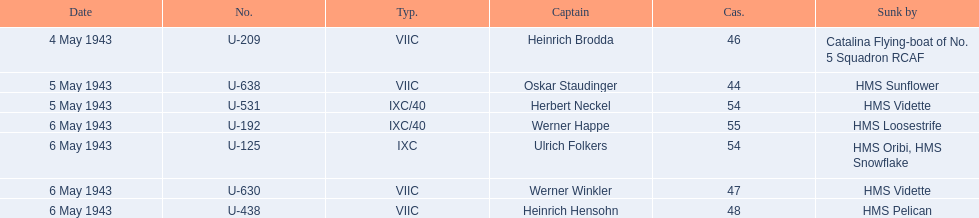Who were the captains in the ons 5 convoy? Heinrich Brodda, Oskar Staudinger, Herbert Neckel, Werner Happe, Ulrich Folkers, Werner Winkler, Heinrich Hensohn. Which ones lost their u-boat on may 5? Oskar Staudinger, Herbert Neckel. Of those, which one is not oskar staudinger? Herbert Neckel. 